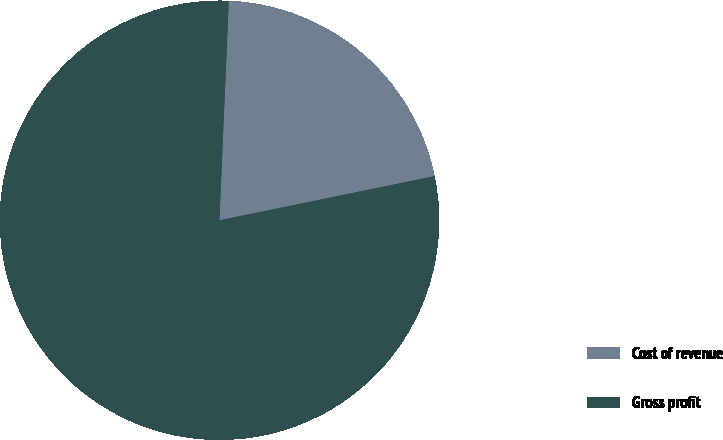<chart> <loc_0><loc_0><loc_500><loc_500><pie_chart><fcel>Cost of revenue<fcel>Gross profit<nl><fcel>21.1%<fcel>78.9%<nl></chart> 